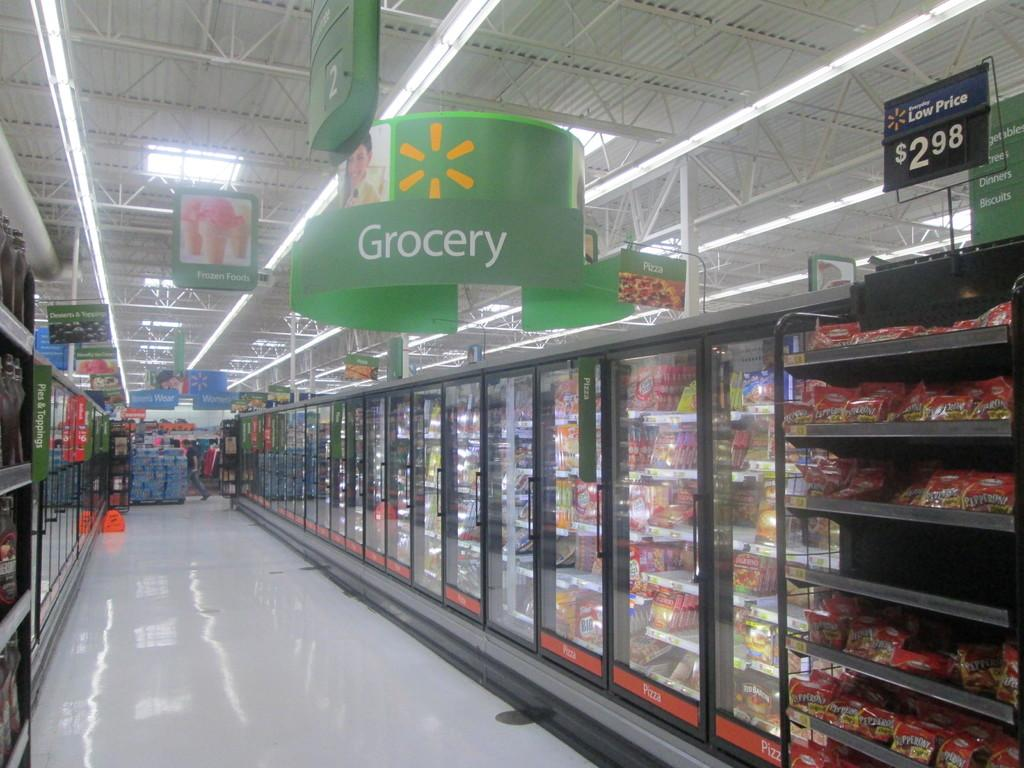<image>
Share a concise interpretation of the image provided. The frozen food aisle of a grocery store. 